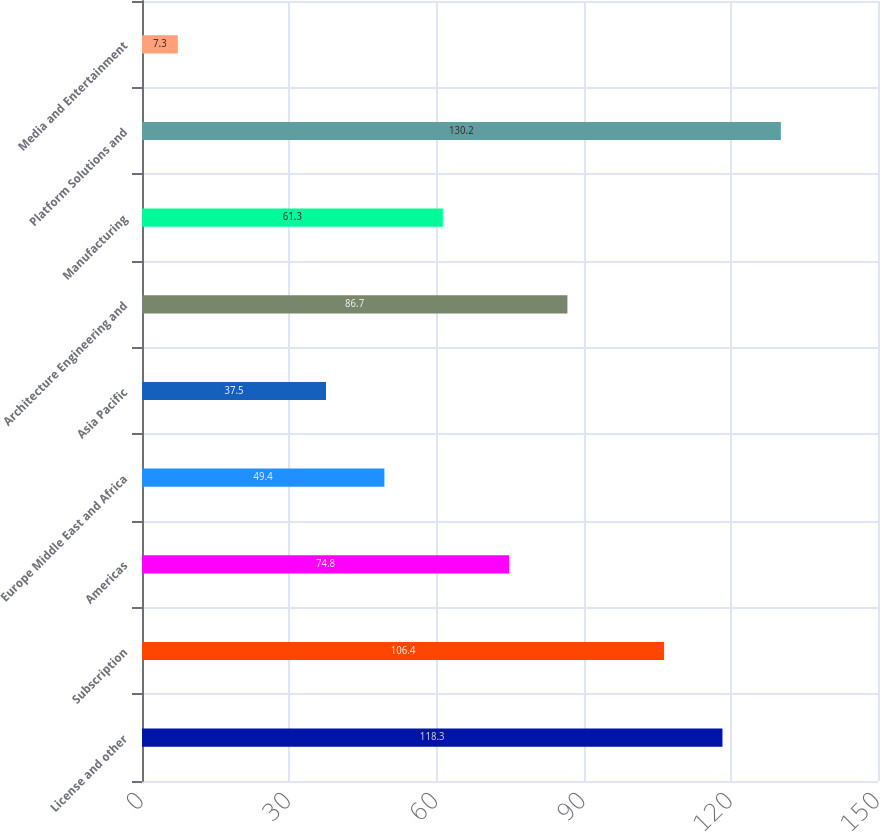Convert chart. <chart><loc_0><loc_0><loc_500><loc_500><bar_chart><fcel>License and other<fcel>Subscription<fcel>Americas<fcel>Europe Middle East and Africa<fcel>Asia Pacific<fcel>Architecture Engineering and<fcel>Manufacturing<fcel>Platform Solutions and<fcel>Media and Entertainment<nl><fcel>118.3<fcel>106.4<fcel>74.8<fcel>49.4<fcel>37.5<fcel>86.7<fcel>61.3<fcel>130.2<fcel>7.3<nl></chart> 